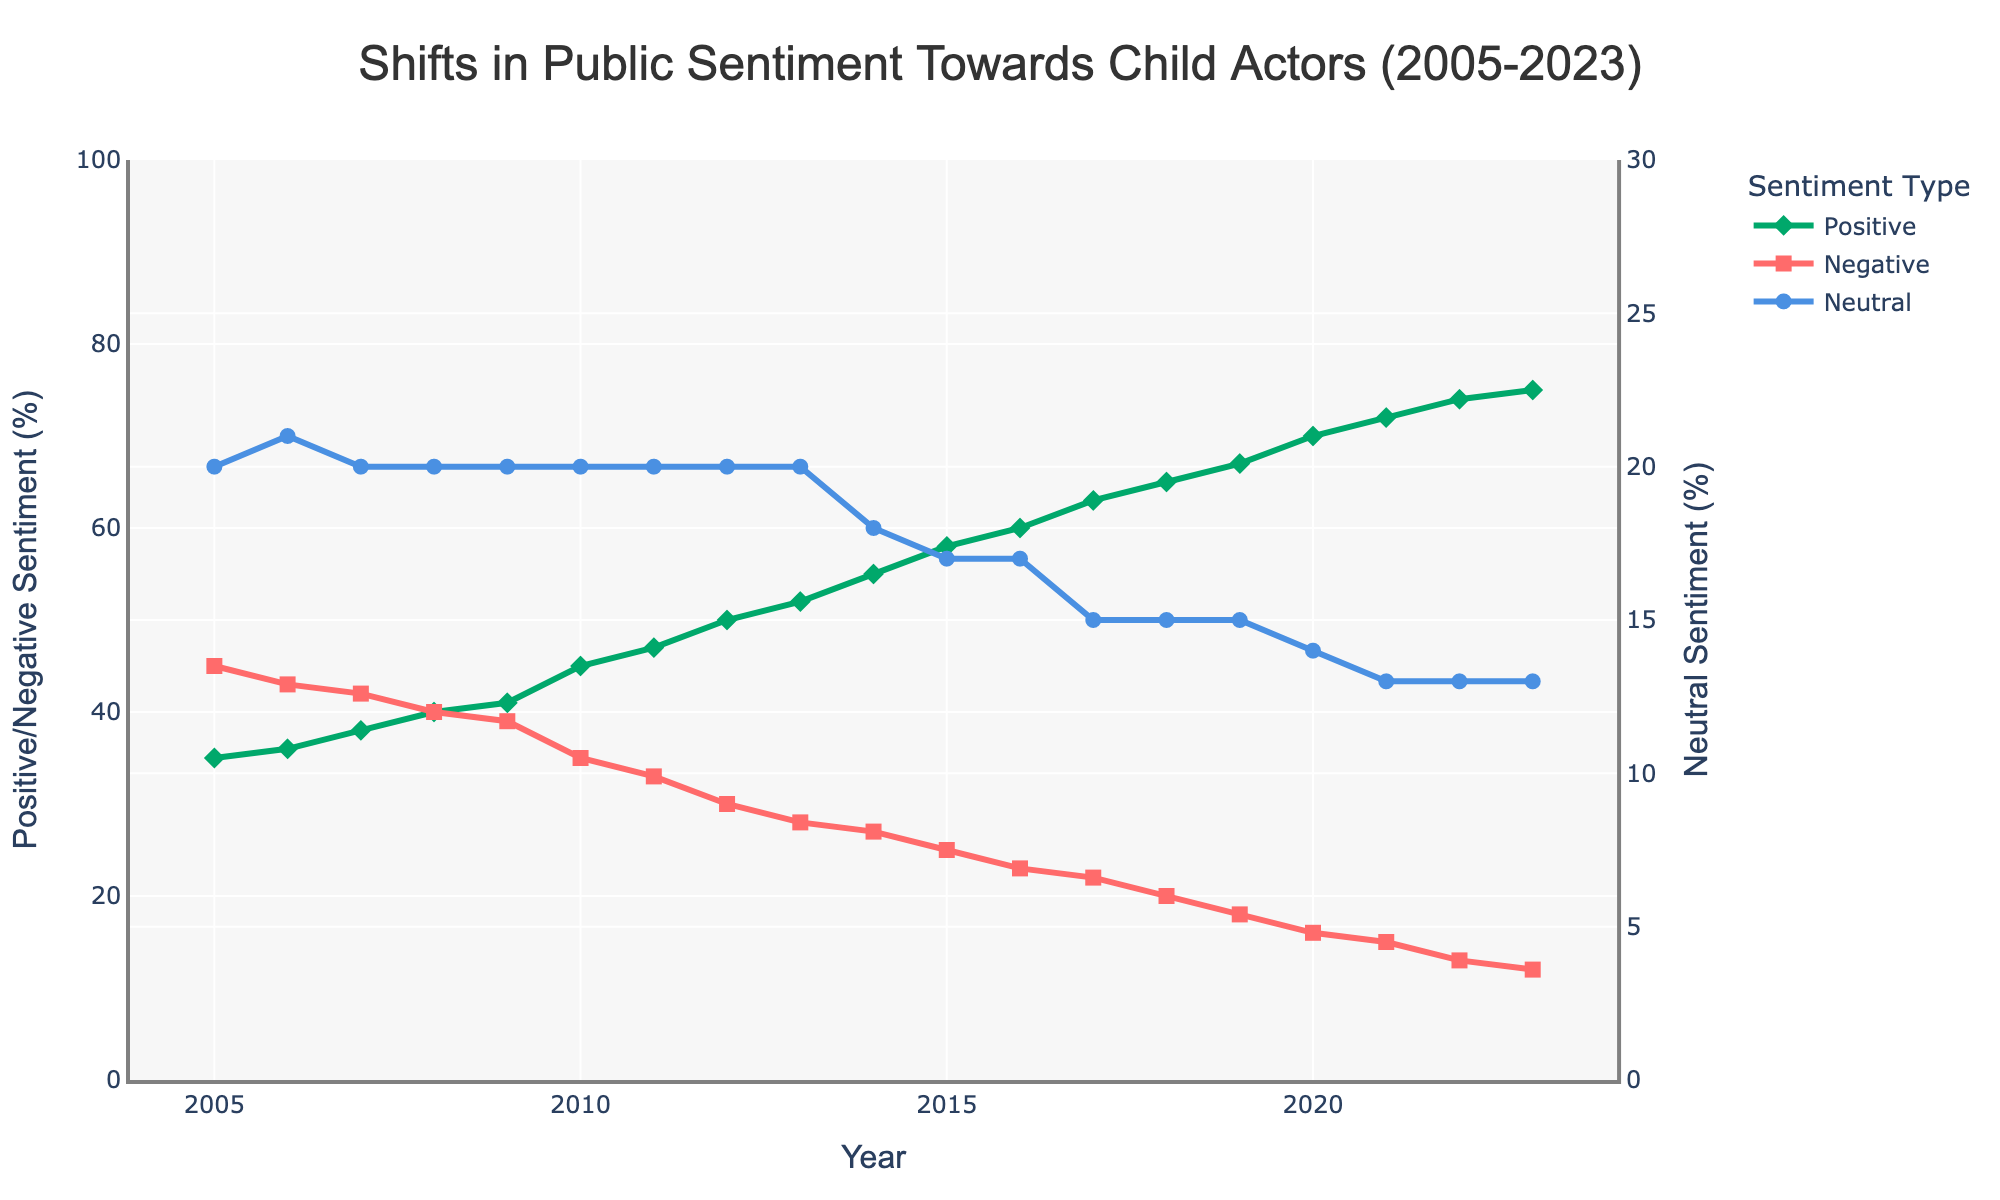What's the overall trend in positive sentiment from 2005 to 2023? The graph shows that positive sentiment towards child actors consistently increases over the years. Starting from 35% in 2005, it rises steadily to 75% in 2023.
Answer: Increasing trend How does the negative sentiment in 2005 compare to the negative sentiment in 2023? The negative sentiment in 2005 is 45%. This steadily decreases over the years to 12% in 2023, indicating a substantial drop.
Answer: Decreases What is the approximate difference between the highest positive sentiment and the lowest negative sentiment observed? The highest positive sentiment is 75% in 2023, and the lowest negative sentiment is 12% in 2023. The difference is 75% - 12% = 63%.
Answer: 63% In which year does neutral sentiment first drop below 20%? Neutral sentiment drops below 20% for the first time in the year 2014, as seen in the graph data.
Answer: 2014 Which sentiment type shows the least variability over the years? Neutral sentiment remains relatively stable across the years with values generally around 20%, showcasing least variability.
Answer: Neutral sentiment What is the difference in positive sentiment between 2005 and 2010? The positive sentiment was 35% in 2005 and increased to 45% by 2010. The difference is 45% - 35% = 10%.
Answer: 10% Which year had the largest increase in positive sentiment compared to the previous year? The largest increase in positive sentiment is observed between 2013 and 2014, increasing from 52% to 55%, which is a 3% increase.
Answer: 2013 to 2014 Between 2012 and 2017, how much did the negative sentiment decrease? From 2012 to 2017, negative sentiment decreases from 30% to 22%. The decrease is 30% - 22% = 8%.
Answer: 8% How many years did it take for positive sentiment to double from its initial value in 2005? Positive sentiment was 35% in 2005. Doubling this value gives 70%. The year it reaches 70% is 2020. Therefore, it took 2020 - 2005 = 15 years for the sentiment to double.
Answer: 15 years Identify the year when all sentiments (positive, negative, and neutral) shift by significant amounts. The year 2010 marks significant sentiment shifts: Positive sentiment increases sharply, negative declines notably, while neutral sentiment stays constant.
Answer: 2010 